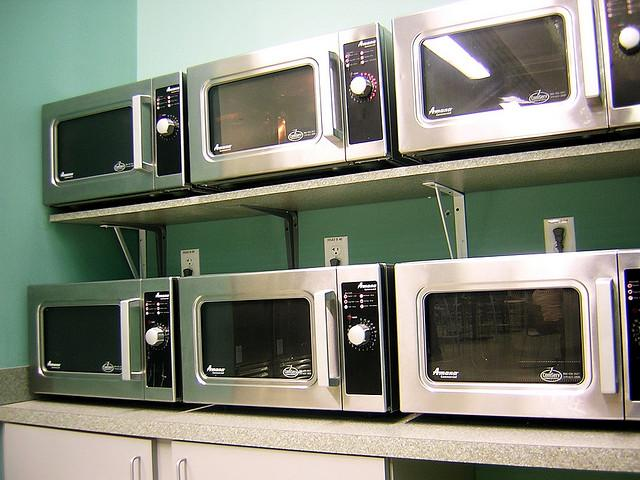Why are there so many microwaves?

Choices:
A) are stolen
B) for sale
C) hiding them
D) many users for sale 